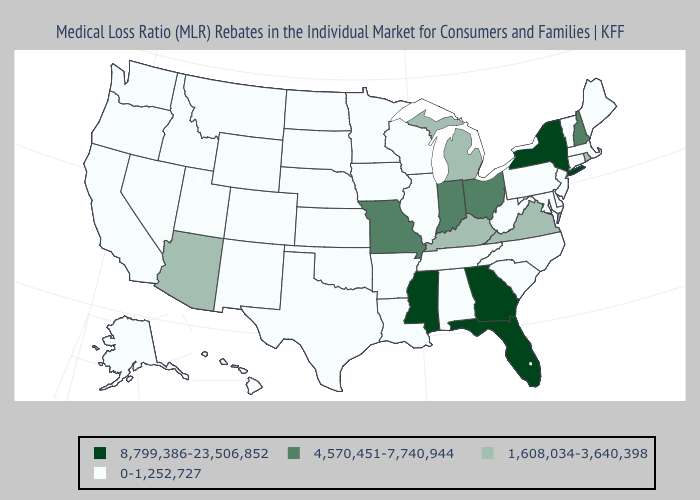How many symbols are there in the legend?
Write a very short answer. 4. Name the states that have a value in the range 1,608,034-3,640,398?
Short answer required. Arizona, Kentucky, Michigan, Rhode Island, Virginia. Which states have the highest value in the USA?
Give a very brief answer. Florida, Georgia, Mississippi, New York. Name the states that have a value in the range 1,608,034-3,640,398?
Be succinct. Arizona, Kentucky, Michigan, Rhode Island, Virginia. What is the value of Washington?
Be succinct. 0-1,252,727. Name the states that have a value in the range 1,608,034-3,640,398?
Concise answer only. Arizona, Kentucky, Michigan, Rhode Island, Virginia. What is the value of Delaware?
Write a very short answer. 0-1,252,727. What is the value of Maine?
Write a very short answer. 0-1,252,727. What is the value of New York?
Quick response, please. 8,799,386-23,506,852. What is the highest value in the USA?
Write a very short answer. 8,799,386-23,506,852. Which states have the highest value in the USA?
Quick response, please. Florida, Georgia, Mississippi, New York. Among the states that border Arkansas , which have the lowest value?
Concise answer only. Louisiana, Oklahoma, Tennessee, Texas. What is the value of New Jersey?
Be succinct. 0-1,252,727. Name the states that have a value in the range 1,608,034-3,640,398?
Keep it brief. Arizona, Kentucky, Michigan, Rhode Island, Virginia. Name the states that have a value in the range 8,799,386-23,506,852?
Short answer required. Florida, Georgia, Mississippi, New York. 